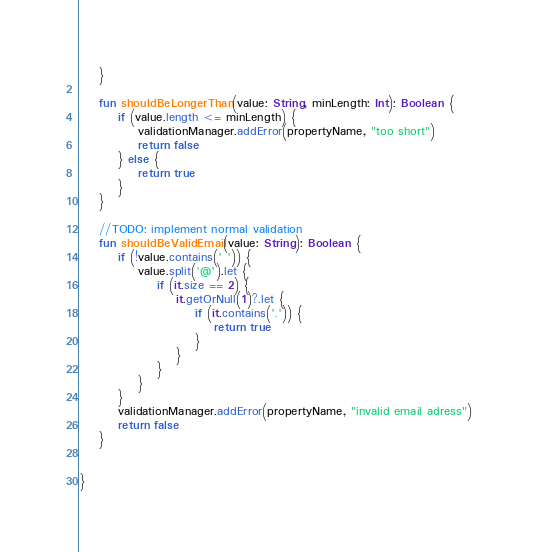Convert code to text. <code><loc_0><loc_0><loc_500><loc_500><_Kotlin_>    }

    fun shouldBeLongerThan(value: String, minLength: Int): Boolean {
        if (value.length <= minLength) {
            validationManager.addError(propertyName, "too short")
            return false
        } else {
            return true
        }
    }

    //TODO: implement normal validation
    fun shouldBeValidEmail(value: String): Boolean {
        if (!value.contains(' ')) {
            value.split('@').let {
                if (it.size == 2) {
                    it.getOrNull(1)?.let {
                        if (it.contains('.')) {
                            return true
                        }
                    }
                }
            }
        }
        validationManager.addError(propertyName, "invalid email adress")
        return false
    }


}</code> 